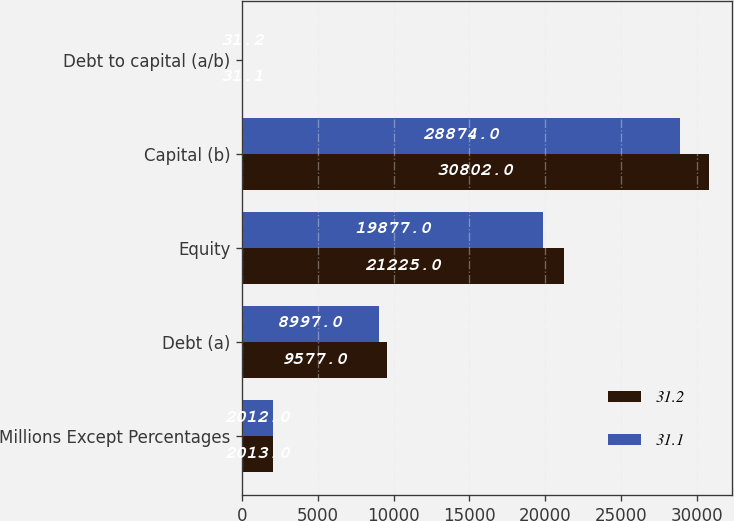Convert chart. <chart><loc_0><loc_0><loc_500><loc_500><stacked_bar_chart><ecel><fcel>Millions Except Percentages<fcel>Debt (a)<fcel>Equity<fcel>Capital (b)<fcel>Debt to capital (a/b)<nl><fcel>31.2<fcel>2013<fcel>9577<fcel>21225<fcel>30802<fcel>31.1<nl><fcel>31.1<fcel>2012<fcel>8997<fcel>19877<fcel>28874<fcel>31.2<nl></chart> 